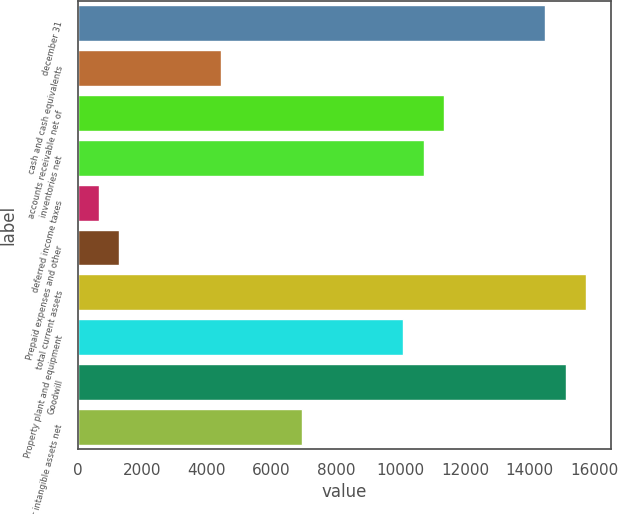<chart> <loc_0><loc_0><loc_500><loc_500><bar_chart><fcel>december 31<fcel>cash and cash equivalents<fcel>accounts receivable net of<fcel>inventories net<fcel>deferred income taxes<fcel>Prepaid expenses and other<fcel>total current assets<fcel>Property plant and equipment<fcel>Goodwill<fcel>other intangible assets net<nl><fcel>14483.1<fcel>4424.52<fcel>11339.8<fcel>10711.1<fcel>652.56<fcel>1281.22<fcel>15740.4<fcel>10082.5<fcel>15111.7<fcel>6939.16<nl></chart> 